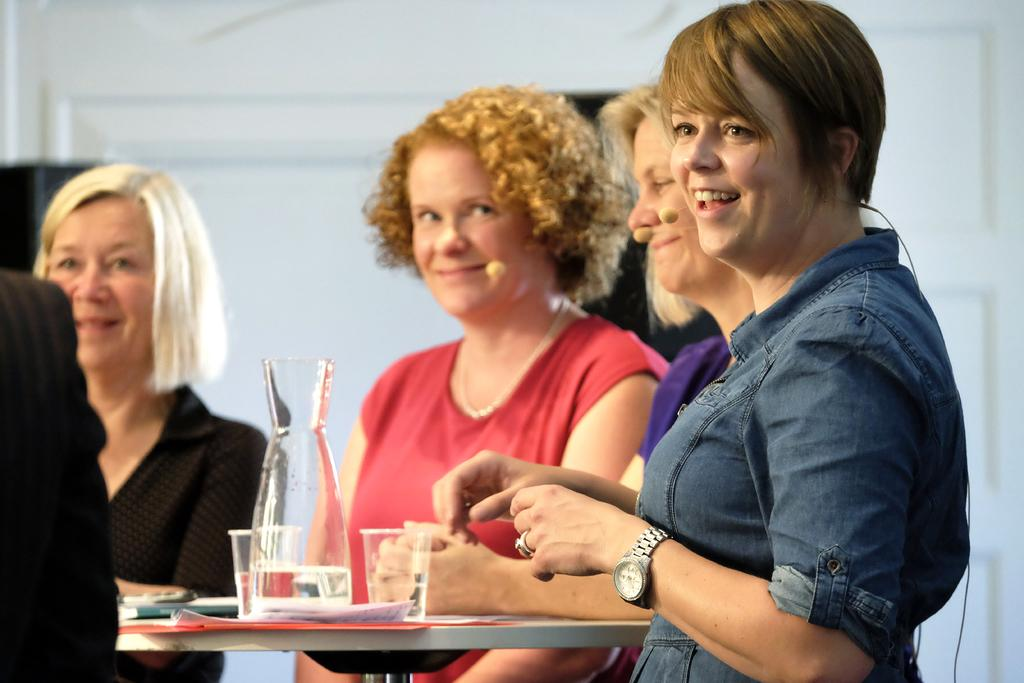How many individuals are present in the image? There are five people in the image. What can be seen on the table in the image? There are many objects on the table in the image. Can you describe the color of the wall in the image? The wall in the image is white. Can you see the fog or breath of the people in the image? There is no mention of fog or breath in the image, so it cannot be determined if they are visible. 